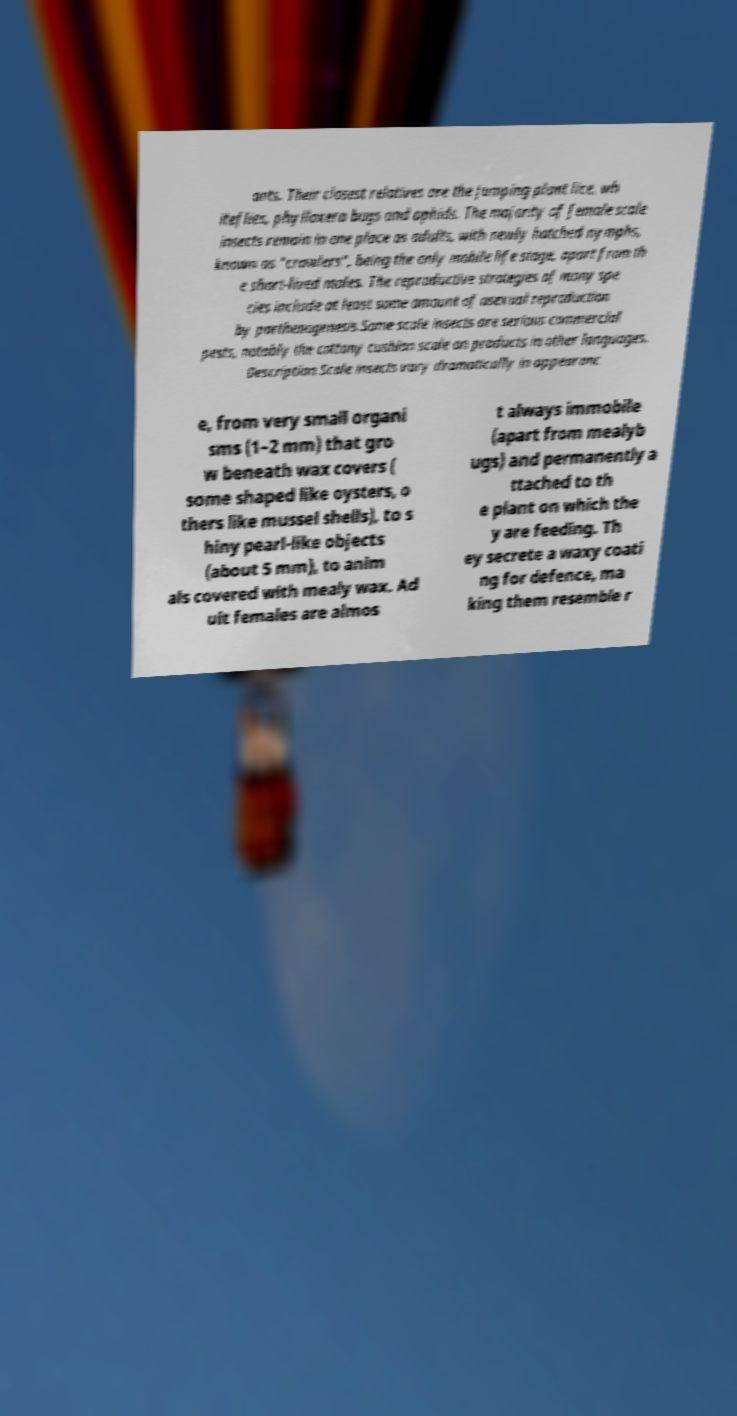Could you assist in decoding the text presented in this image and type it out clearly? ants. Their closest relatives are the jumping plant lice, wh iteflies, phylloxera bugs and aphids. The majority of female scale insects remain in one place as adults, with newly hatched nymphs, known as "crawlers", being the only mobile life stage, apart from th e short-lived males. The reproductive strategies of many spe cies include at least some amount of asexual reproduction by parthenogenesis.Some scale insects are serious commercial pests, notably the cottony cushion scale on products in other languages. Description.Scale insects vary dramatically in appearanc e, from very small organi sms (1–2 mm) that gro w beneath wax covers ( some shaped like oysters, o thers like mussel shells), to s hiny pearl-like objects (about 5 mm), to anim als covered with mealy wax. Ad ult females are almos t always immobile (apart from mealyb ugs) and permanently a ttached to th e plant on which the y are feeding. Th ey secrete a waxy coati ng for defence, ma king them resemble r 